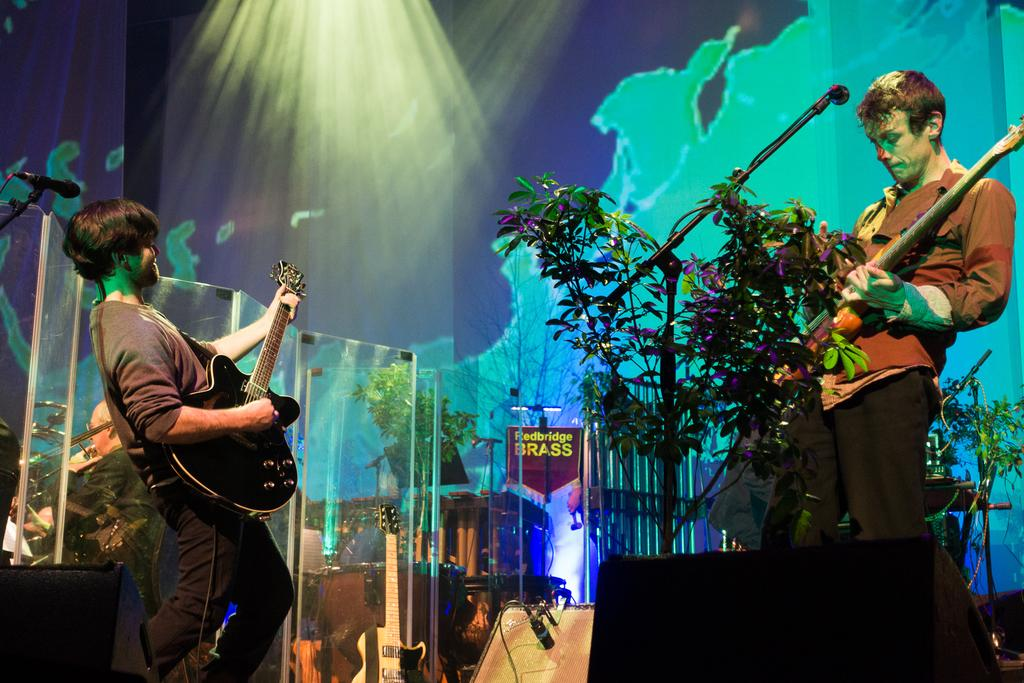How many people are in the image? There are two persons in the image. What are the two persons doing in the image? The two persons are playing guitar. What object is in front of the guitar players? There is a microphone in front of the guitar players. What can be seen in the background of the image? There are trees visible in the background of the image. What type of plants are being offered by the guitar players in the image? There are no plants being offered in the image, as the guitar players are focused on playing their instruments. 